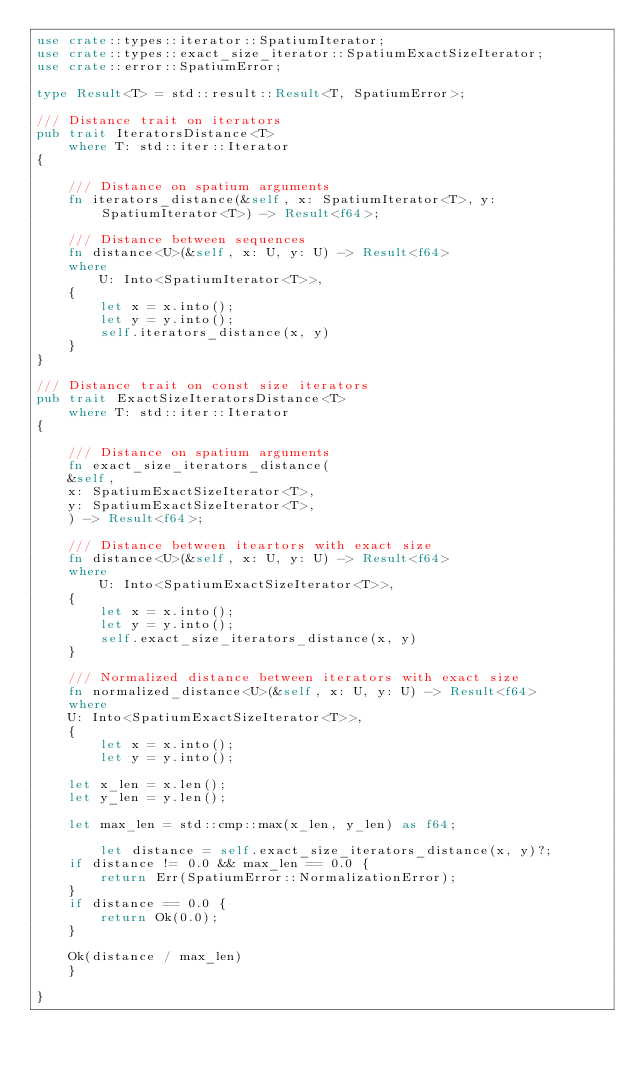<code> <loc_0><loc_0><loc_500><loc_500><_Rust_>use crate::types::iterator::SpatiumIterator;
use crate::types::exact_size_iterator::SpatiumExactSizeIterator;
use crate::error::SpatiumError;

type Result<T> = std::result::Result<T, SpatiumError>;

/// Distance trait on iterators
pub trait IteratorsDistance<T>
    where T: std::iter::Iterator
{

    /// Distance on spatium arguments
    fn iterators_distance(&self, x: SpatiumIterator<T>, y: SpatiumIterator<T>) -> Result<f64>;

    /// Distance between sequences
    fn distance<U>(&self, x: U, y: U) -> Result<f64>
    where
        U: Into<SpatiumIterator<T>>,
    {
        let x = x.into();
        let y = y.into();
        self.iterators_distance(x, y)
    }
}

/// Distance trait on const size iterators
pub trait ExactSizeIteratorsDistance<T>
    where T: std::iter::Iterator
{

    /// Distance on spatium arguments
    fn exact_size_iterators_distance(
	&self,
	x: SpatiumExactSizeIterator<T>,
	y: SpatiumExactSizeIterator<T>,
    ) -> Result<f64>;

    /// Distance between iteartors with exact size
    fn distance<U>(&self, x: U, y: U) -> Result<f64>
    where
        U: Into<SpatiumExactSizeIterator<T>>,
    {
        let x = x.into();
        let y = y.into();
        self.exact_size_iterators_distance(x, y)
    }

    /// Normalized distance between iterators with exact size
    fn normalized_distance<U>(&self, x: U, y: U) -> Result<f64>
    where
	U: Into<SpatiumExactSizeIterator<T>>,
    {
        let x = x.into();
        let y = y.into();

	let x_len = x.len();
	let y_len = y.len();

	let max_len = std::cmp::max(x_len, y_len) as f64;

        let distance = self.exact_size_iterators_distance(x, y)?;
	if distance != 0.0 && max_len == 0.0 {
	    return Err(SpatiumError::NormalizationError);
	}
	if distance == 0.0 {
	    return Ok(0.0);
	}

	Ok(distance / max_len)
    }

}

</code> 